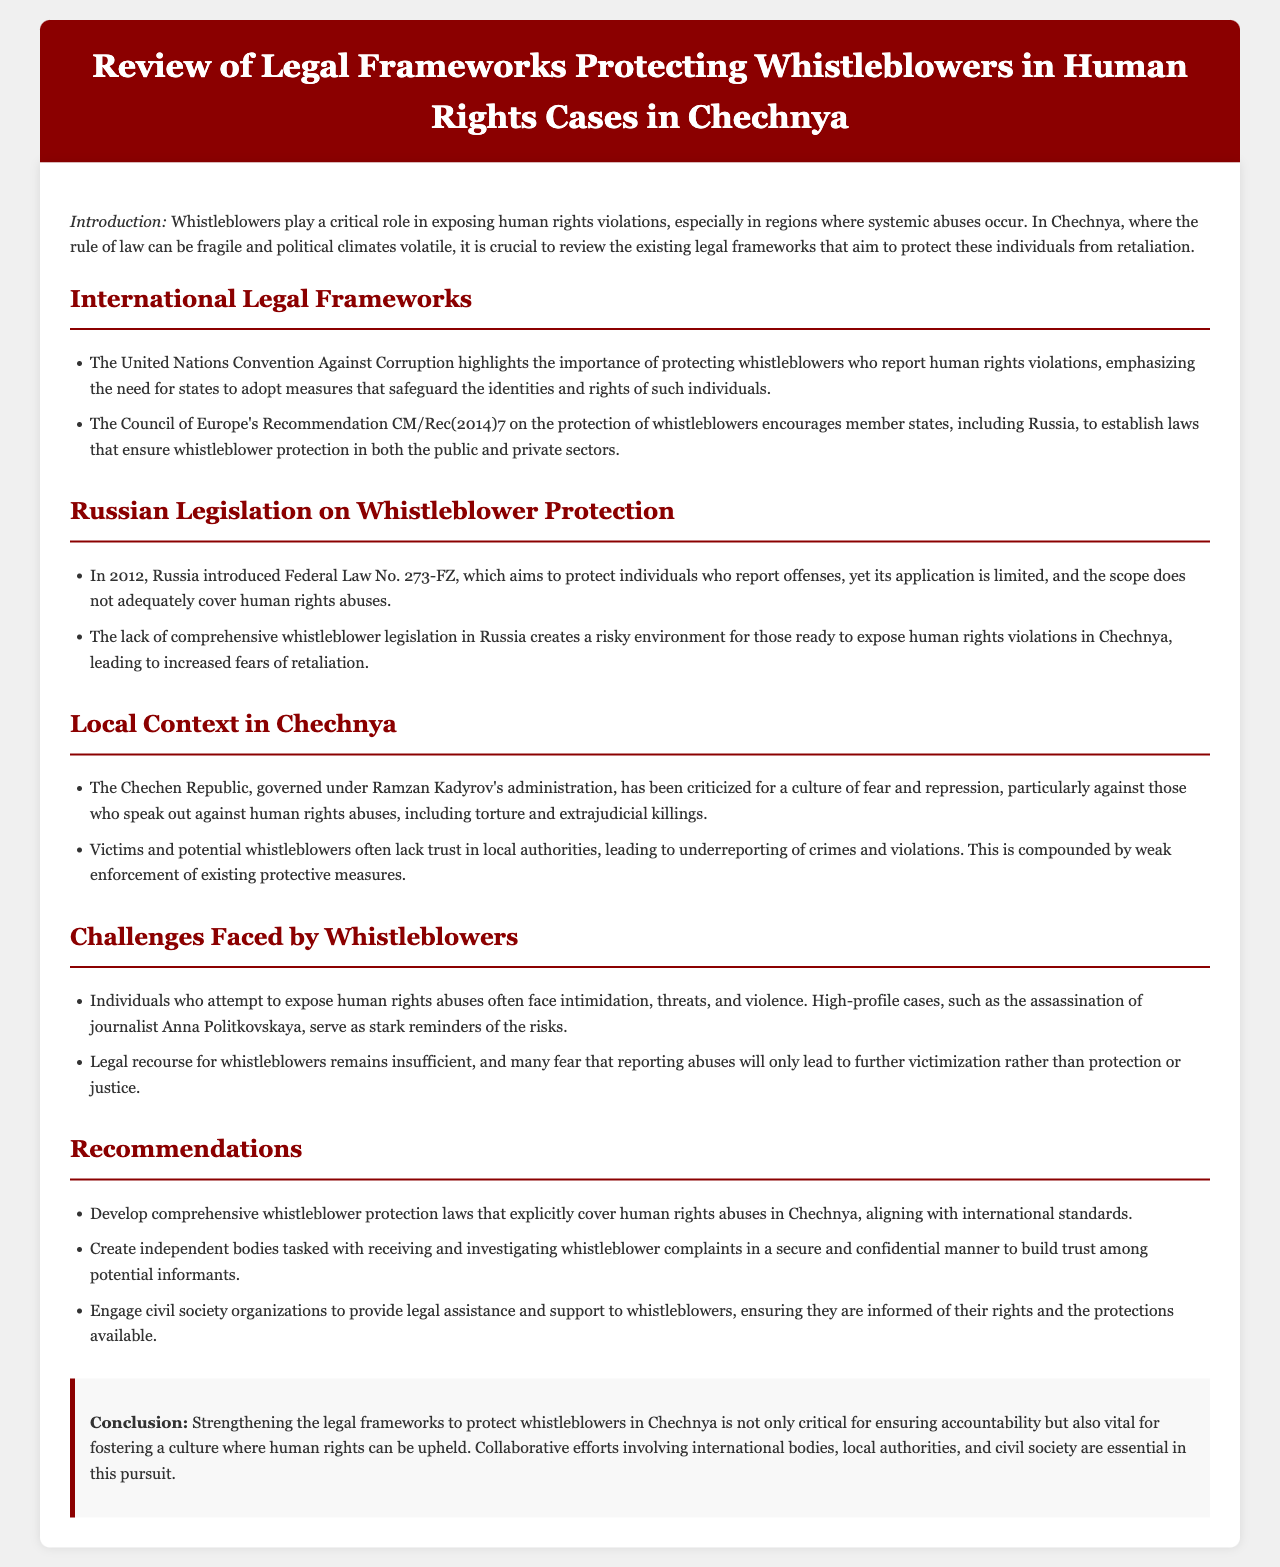What is the title of the report? The title is explicitly mentioned in the header section of the document, which presents the main topic being discussed.
Answer: Review of Legal Frameworks Protecting Whistleblowers in Human Rights Cases in Chechnya What year was Federal Law No. 273-FZ introduced in Russia? The document clearly lists the year of introduction of the law under the section discussing Russian Legislation.
Answer: 2012 What do the United Nations advocate for regarding whistleblowers? The section on International Legal Frameworks provides insights into what measures should be adopted to protect whistleblowers.
Answer: Protecting whistleblowers who report human rights violations Who governs the Chechen Republic? The document mentions the governing authority in the context of local challenges faced by whistleblowers.
Answer: Ramzan Kadyrov What major threat do individuals face when exposing human rights violations? In the Challenges Faced by Whistleblowers section, specific risks associated with whistleblowing are discussed.
Answer: Intimidation What is one recommendation made in the report? The report contains several recommendations, one of which is explicitly highlighted for improving whistleblower protection.
Answer: Develop comprehensive whistleblower protection laws 